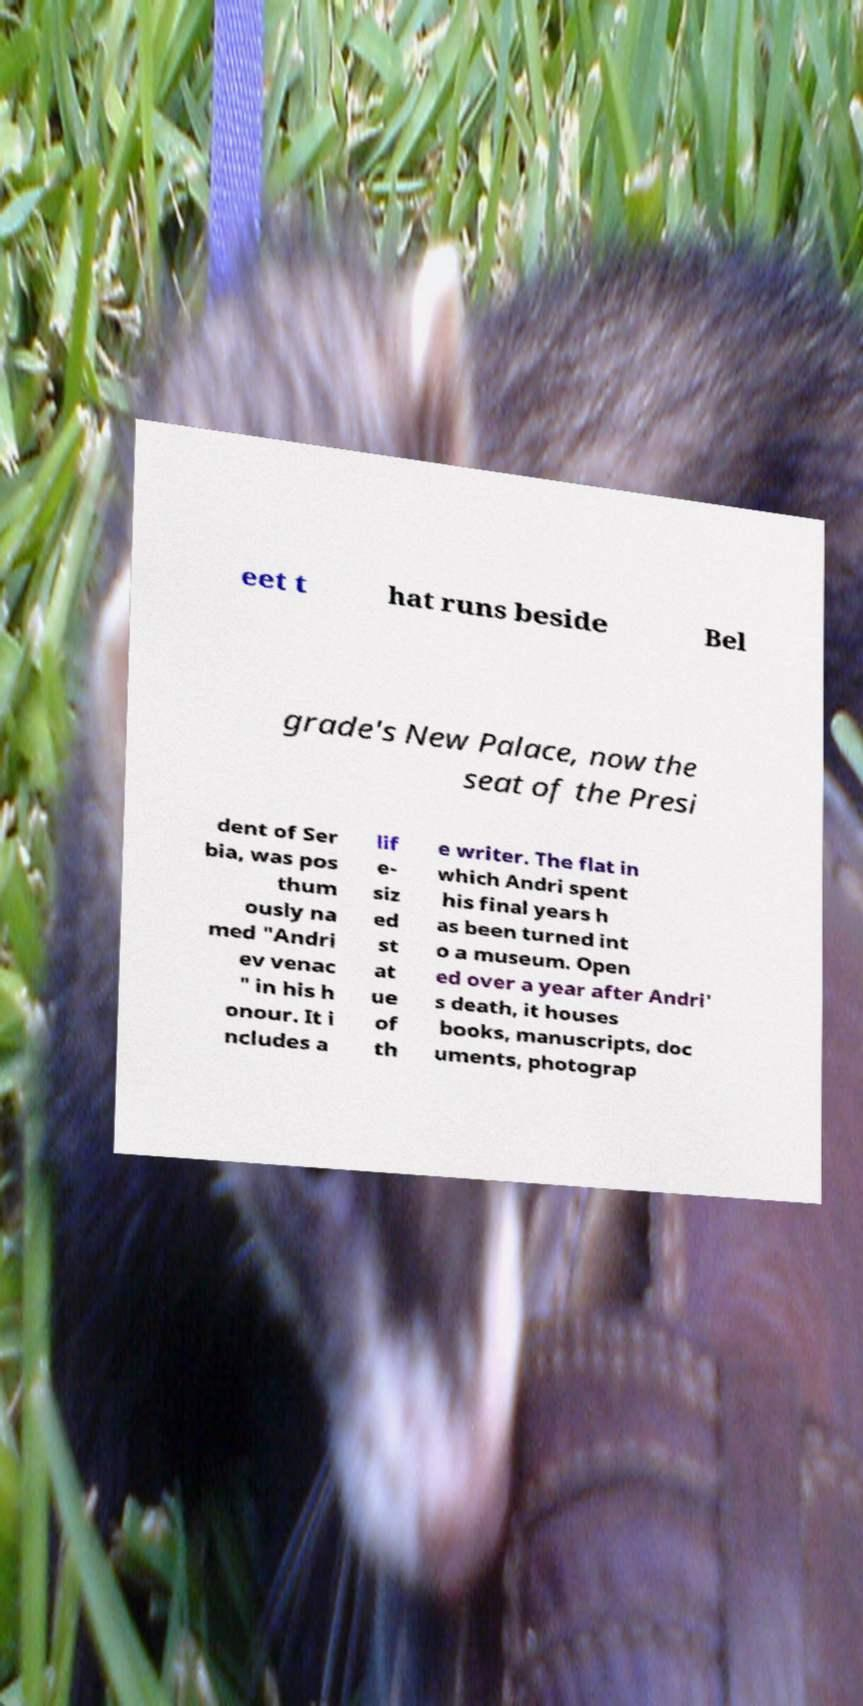For documentation purposes, I need the text within this image transcribed. Could you provide that? eet t hat runs beside Bel grade's New Palace, now the seat of the Presi dent of Ser bia, was pos thum ously na med "Andri ev venac " in his h onour. It i ncludes a lif e- siz ed st at ue of th e writer. The flat in which Andri spent his final years h as been turned int o a museum. Open ed over a year after Andri' s death, it houses books, manuscripts, doc uments, photograp 